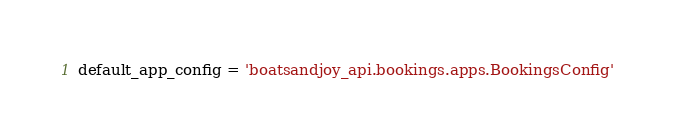Convert code to text. <code><loc_0><loc_0><loc_500><loc_500><_Python_>default_app_config = 'boatsandjoy_api.bookings.apps.BookingsConfig'
</code> 